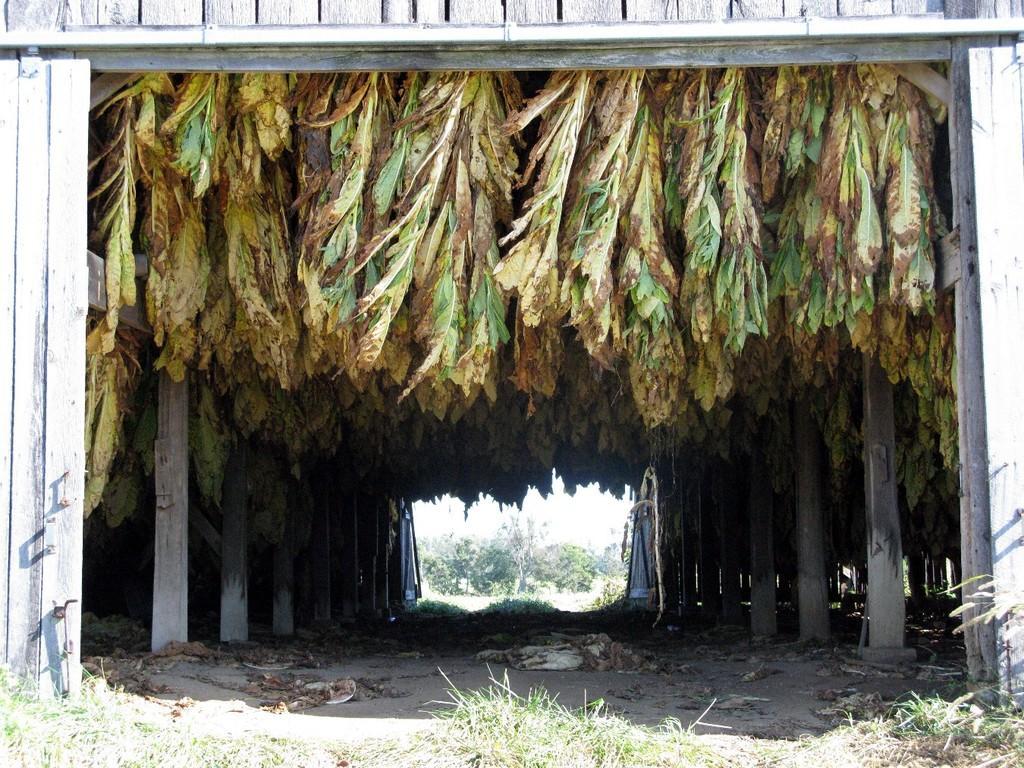Could you give a brief overview of what you see in this image? In this image, we can see wooden wall. There are leaves in the middle of the image. There are pillars on the left and on the right side of the image. 